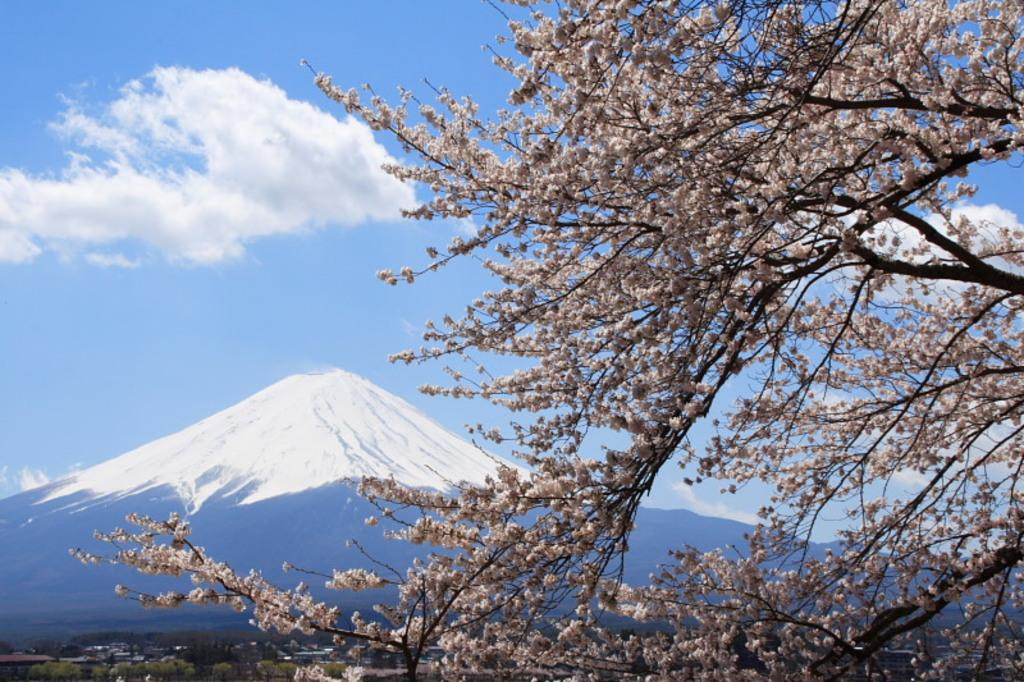What is present on the branches of the tree in the image? There is a group of flowers on the branches of a tree in the image. What can be seen in the distance behind the tree? Mountains are visible in the background of the image. How would you describe the sky in the image? The sky is cloudy in the background of the image. How many books are stacked under the tree in the image? There are no books present in the image; it features a tree with flowers and a cloudy sky in the background. 